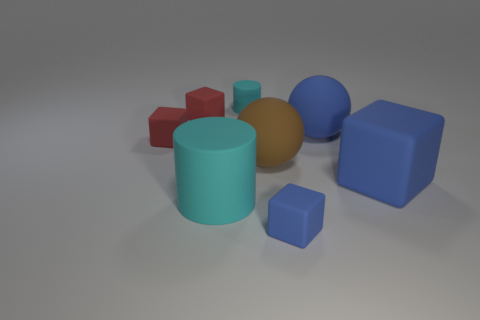Add 2 yellow things. How many objects exist? 10 Subtract 0 brown cylinders. How many objects are left? 8 Subtract all blue cubes. How many were subtracted if there are1blue cubes left? 1 Subtract all spheres. How many objects are left? 6 Subtract 2 blocks. How many blocks are left? 2 Subtract all green cylinders. Subtract all blue blocks. How many cylinders are left? 2 Subtract all blue cylinders. How many gray blocks are left? 0 Subtract all big brown objects. Subtract all tiny matte blocks. How many objects are left? 4 Add 5 tiny cyan rubber cylinders. How many tiny cyan rubber cylinders are left? 6 Add 3 big brown rubber things. How many big brown rubber things exist? 4 